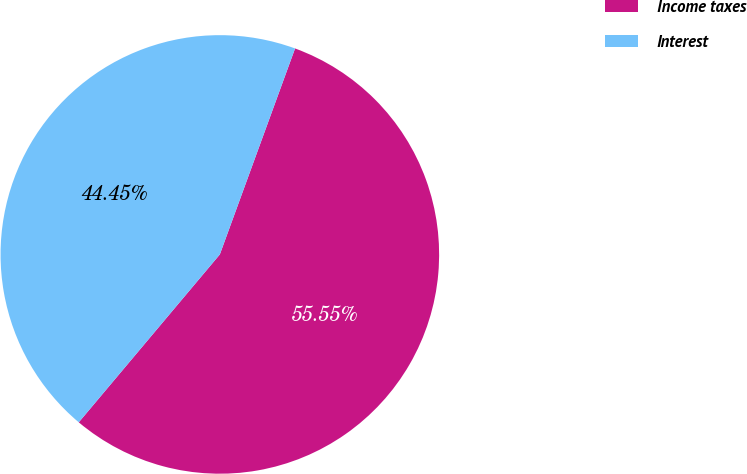<chart> <loc_0><loc_0><loc_500><loc_500><pie_chart><fcel>Income taxes<fcel>Interest<nl><fcel>55.55%<fcel>44.45%<nl></chart> 